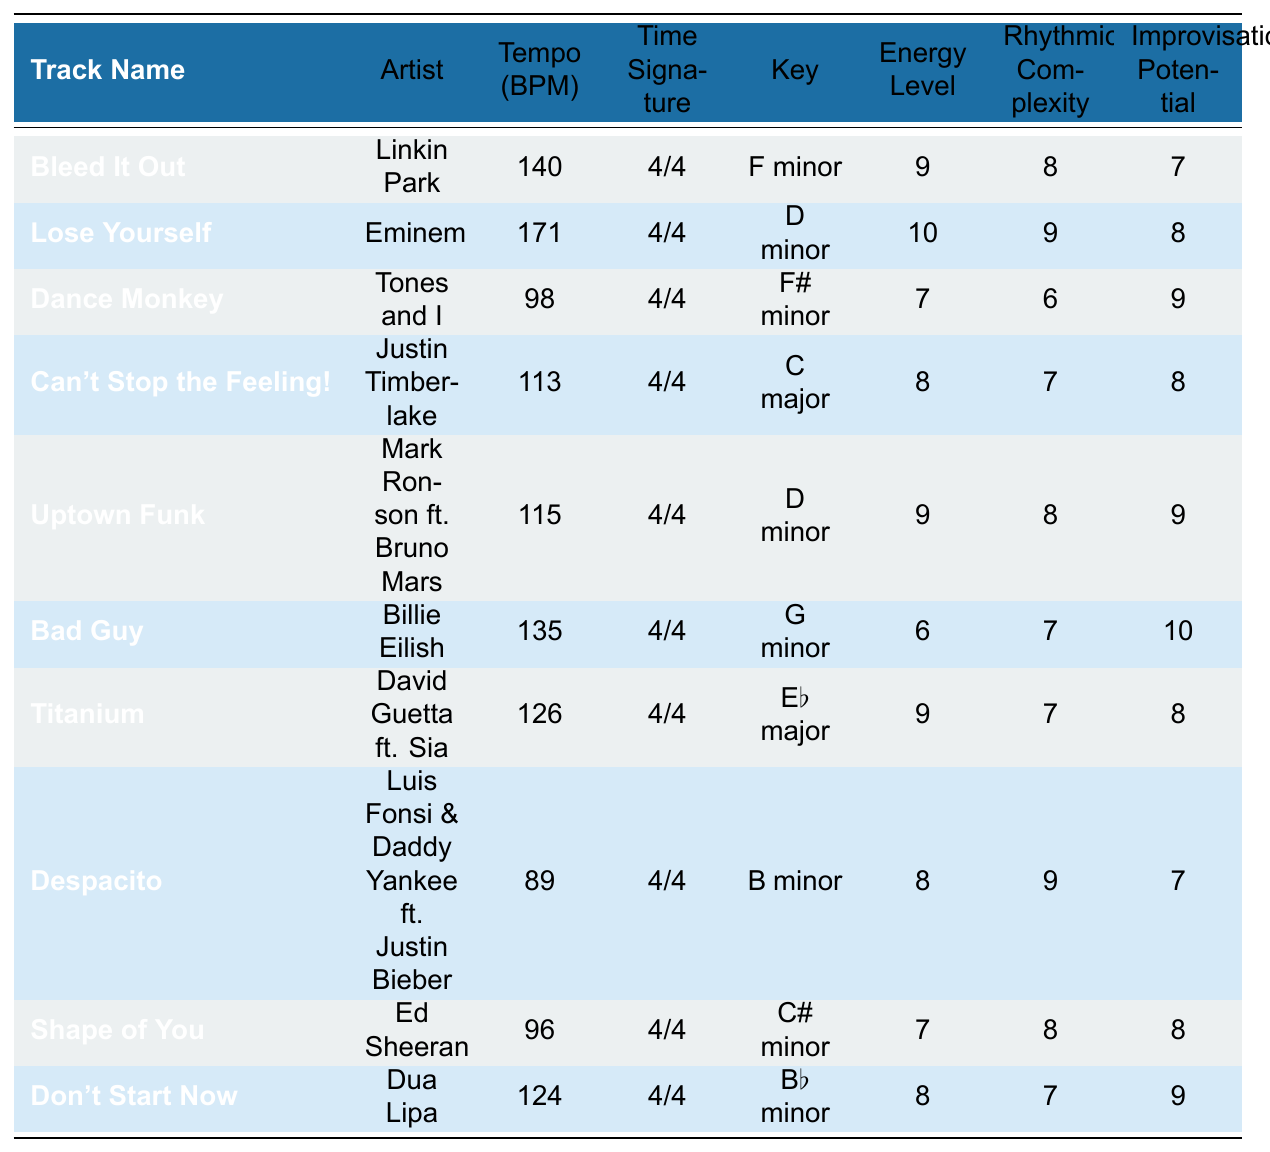What is the tempo of "Uptown Funk"? The tempo of "Uptown Funk" is mentioned directly in the table under "Tempo (BPM)", which shows 115 BPM.
Answer: 115 BPM Which artist performed "Lose Yourself"? The artist for "Lose Yourself" is listed in the table as Eminem.
Answer: Eminem What is the energy level of "Bad Guy"? The energy level for "Bad Guy" can be found in the table under "Energy Level", which is 6.
Answer: 6 How many tracks have a tempo greater than 130 BPM? By checking the tempos in the table, "Lose Yourself" (171 BPM) and "Bleed It Out" (140 BPM) are the only tracks exceeding 130 BPM, totaling 2 tracks.
Answer: 2 What is the average energy level of the tracks listed? To find the average, sum the energy levels: 9 + 10 + 7 + 8 + 9 + 6 + 9 + 8 + 7 + 8 = 81. There are 10 tracks, so the average is 81/10 = 8.1.
Answer: 8.1 Which track has the highest rhythmic complexity? The highest rhythmic complexity in the table is found in "Lose Yourself" with a complexity score of 9.
Answer: Lose Yourself Is the time signature for all tracks the same? By reviewing the table, all tracks share the time signature of "4/4", confirming they are the same.
Answer: Yes Which artist has the lowest improvisation potential score? Checking the improvisation potential scores, "Bleed It Out" has the lowest score of 7 among the listed tracks.
Answer: Bleed It Out What is the key of the track "Dance Monkey"? The key of "Dance Monkey" is found in the table, which states it is in F# minor.
Answer: F# minor Considering all the tracks, which one has the highest tempo and what is its value? "Lose Yourself" has the highest tempo at 171 BPM, as noted in the tempo column of the table.
Answer: 171 BPM 